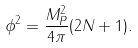<formula> <loc_0><loc_0><loc_500><loc_500>\phi ^ { 2 } = \frac { M _ { P } ^ { 2 } } { 4 \pi } ( 2 N + 1 ) .</formula> 